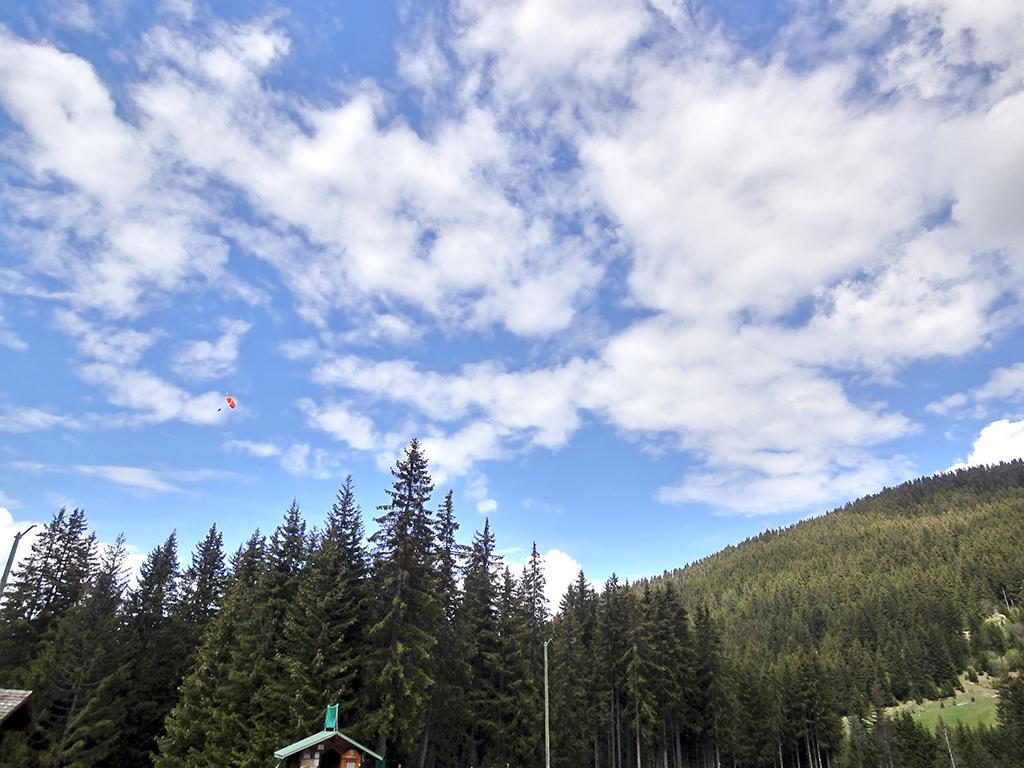In one or two sentences, can you explain what this image depicts? There are trees and roofs at the bottom side of the image and there is a mountain, it seems like parachute and sky in the background area. 